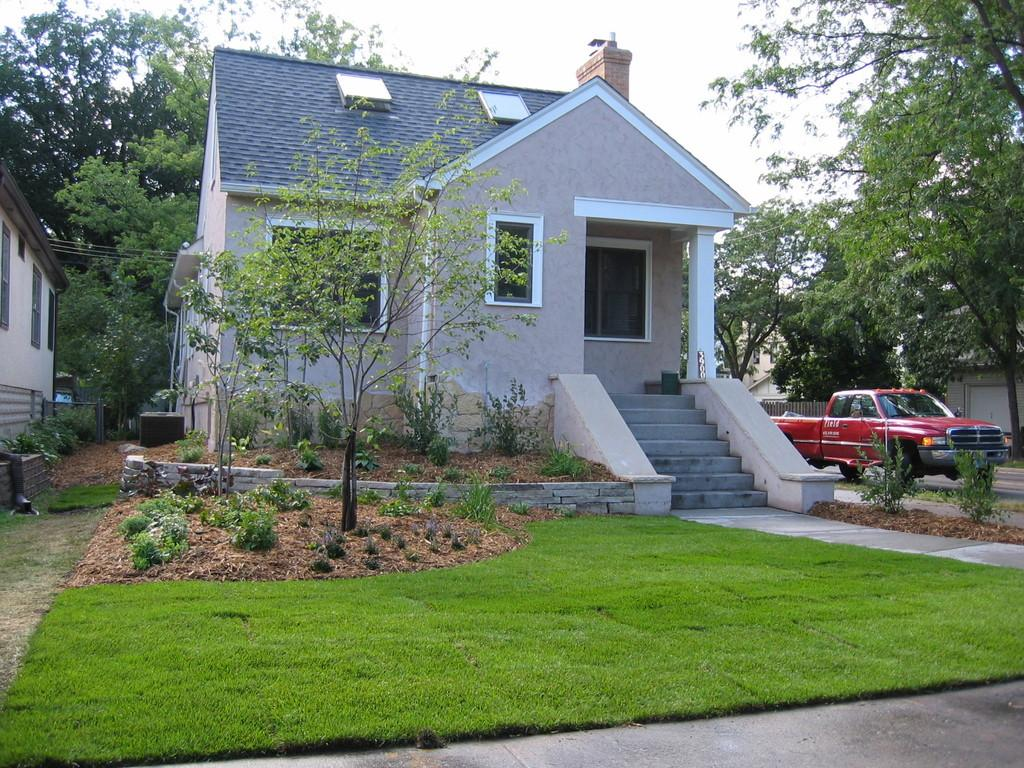What type of structures can be seen in the image? There are houses in the image. What is located in front of the houses? There are plants in front of the houses. What can be seen to the right of the houses? There is a vehicle to the right of the houses. What is visible in the background of the image? There are many trees and the sky in the background of the image. What degree of difficulty is the celery being used for in the image? There is no celery present in the image, so it cannot be used for any degree of difficulty. 